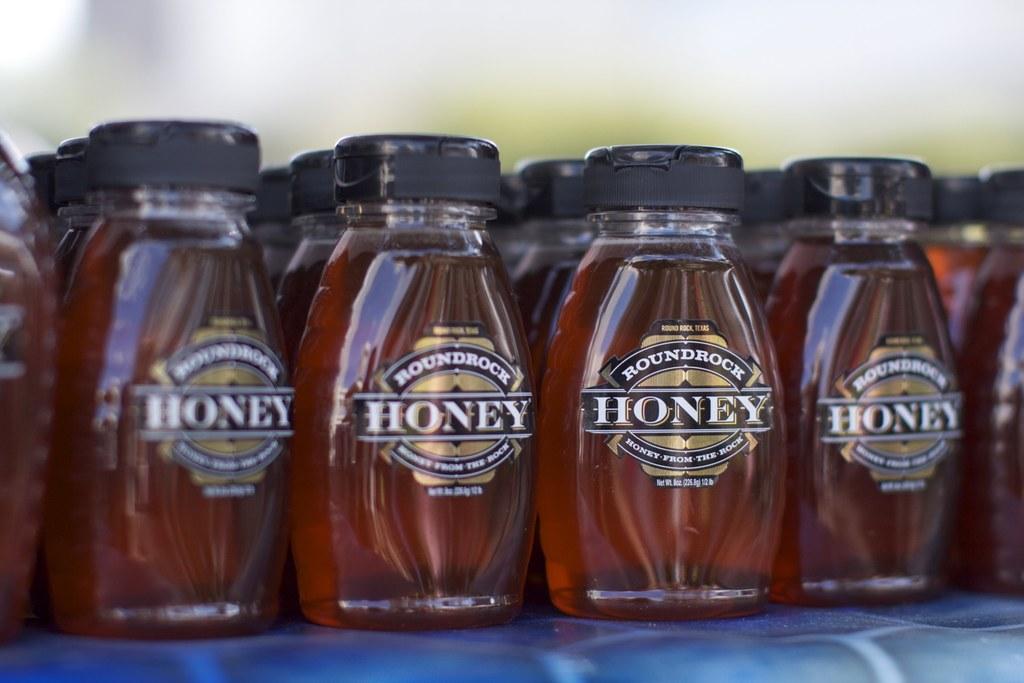What is in these jars?
Provide a succinct answer. Honey. Which company made the honey?
Offer a very short reply. Roundrock. 